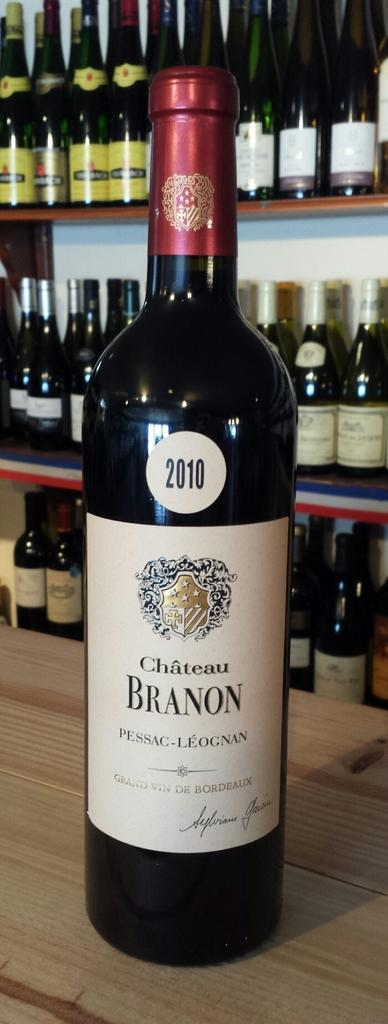Provide a one-sentence caption for the provided image. a bottle of chateau branon from 2010 sitting on a bar. 